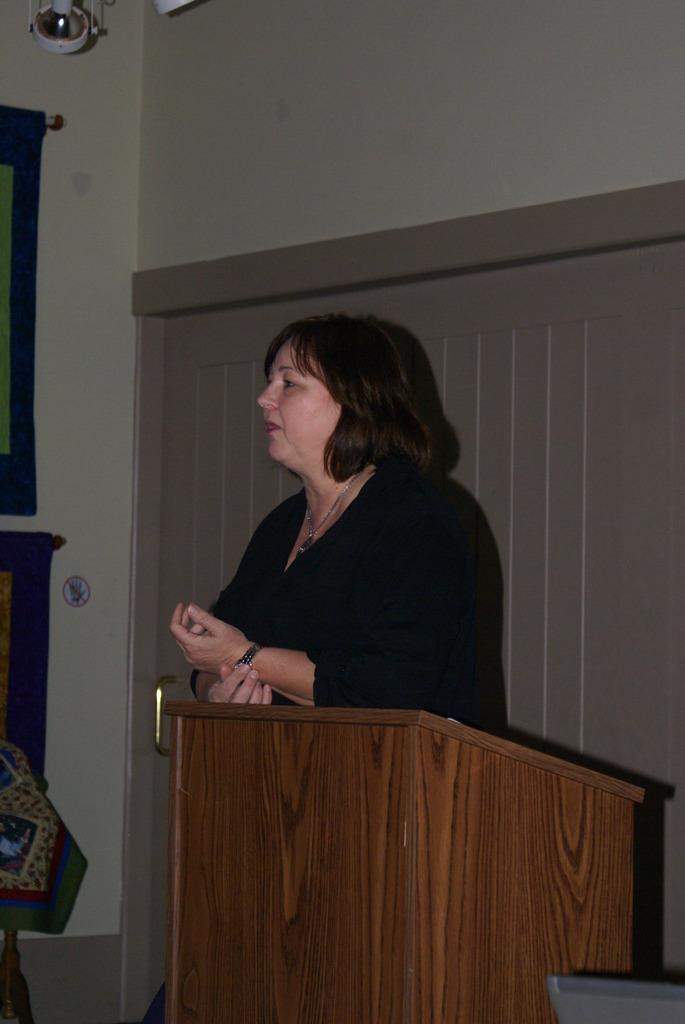What is the color and type of object that the woman is standing near in the image? There is a brown color podium in the image, and the woman is standing near it. Can you describe the woman's appearance or actions in the image? The provided facts do not mention the woman's appearance or actions. What can be seen in the background of the image? There is a door and a wall visible in the background of the image. What direction is the woman facing in relation to the north in the image? The provided facts do not mention the direction the woman is facing, nor is there any information about the north in the image. Are there any bushes visible in the image? There is no mention of bushes in the provided facts, so we cannot determine if they are present in the image. 